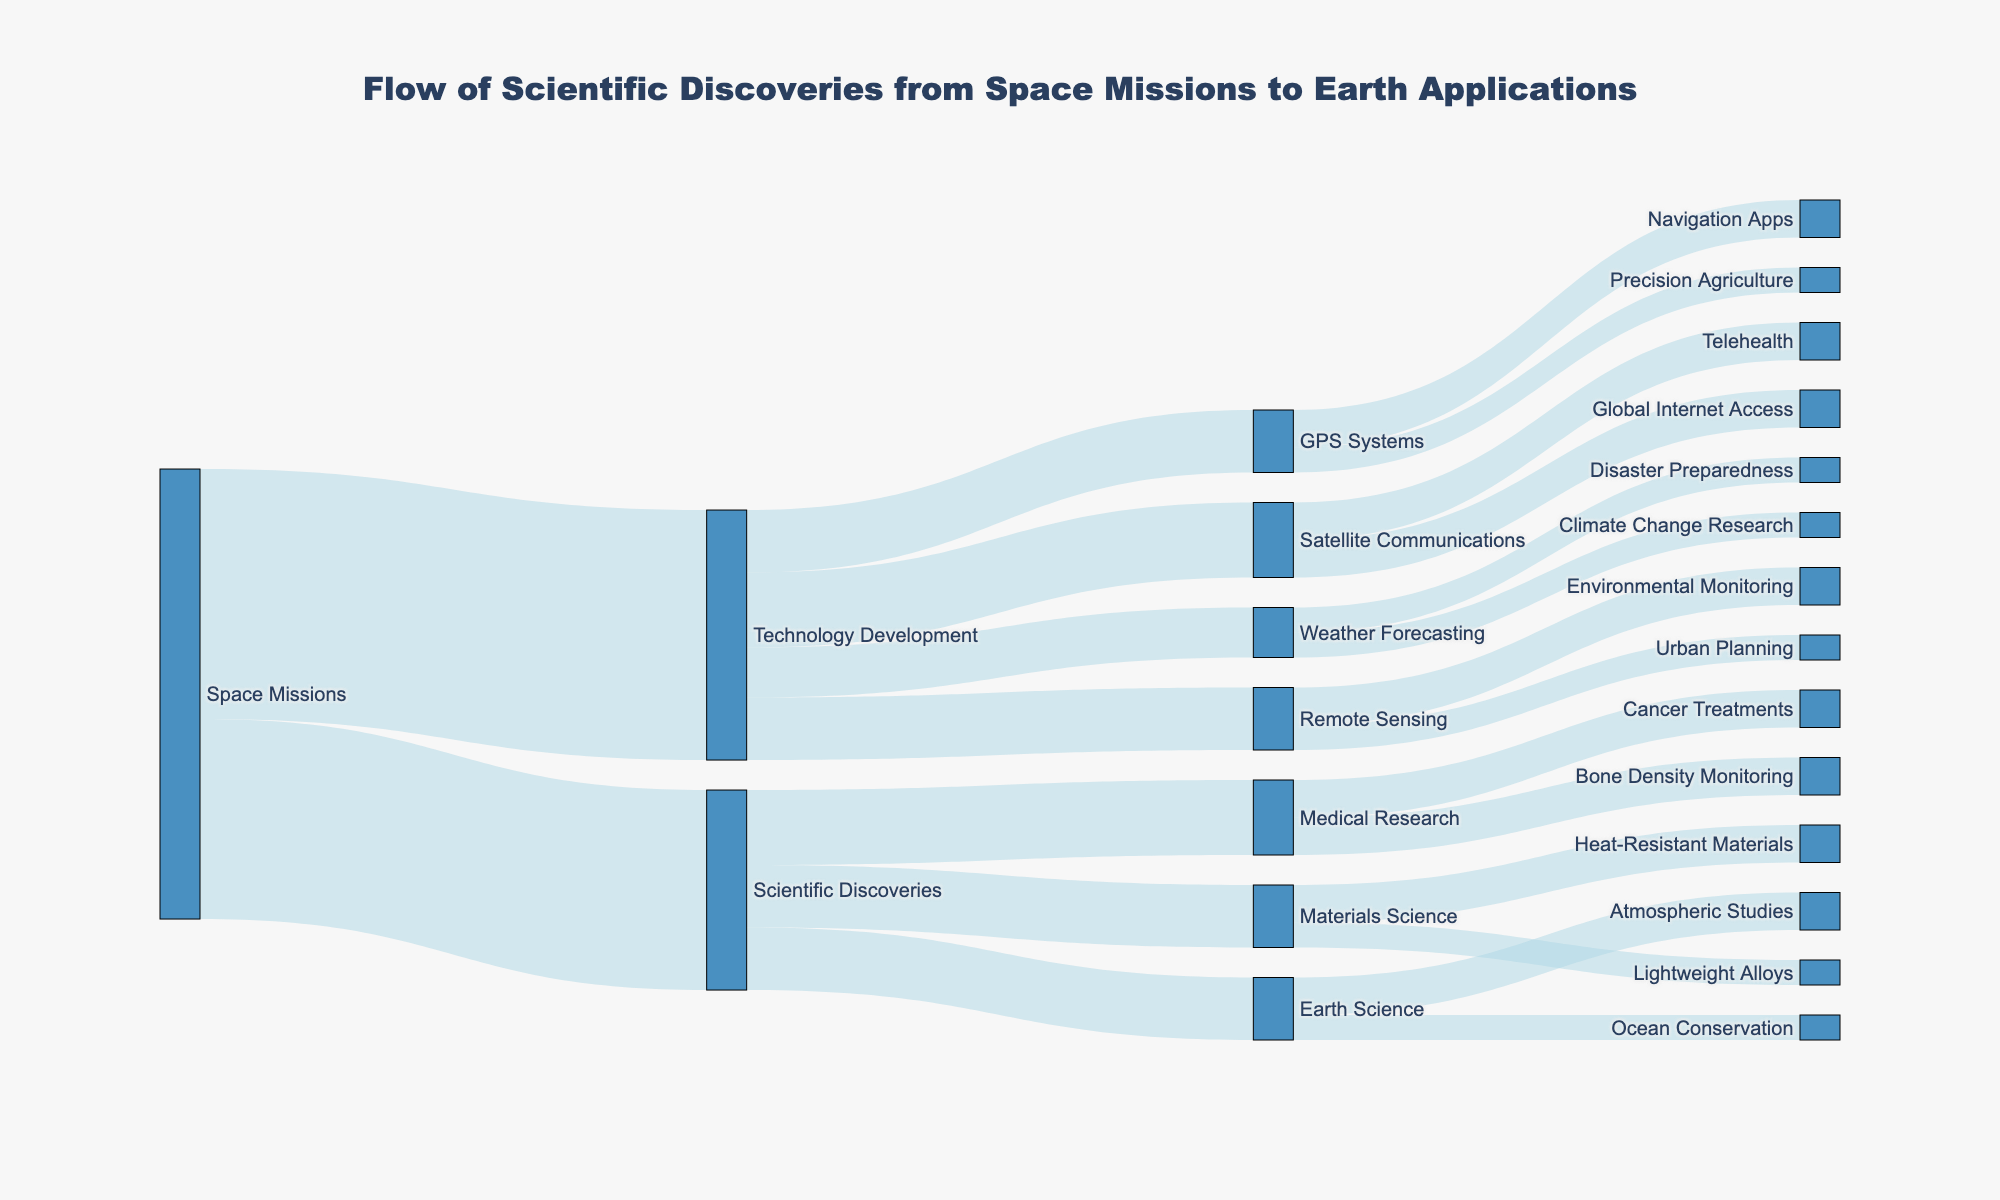What is the main source of the data flow in the diagram? The Sankey Diagram shows that "Space Missions" is the initial source from which the flow begins to different targets like Technology Development and Scientific Discoveries.
Answer: Space Missions How many units of value flow from Technology Development to GPS Systems? According to the figure, there is a flow of 25 units from "Technology Development" to "GPS Systems".
Answer: 25 Which target receives the highest amount of flow from Scientific Discoveries? From the Sankey Diagram, "Medical Research" receives the highest flow from "Scientific Discoveries" with a value of 30 units.
Answer: Medical Research Compare the flow values from Space Missions to Technology Development and from Space Missions to Scientific Discoveries. Which is higher? The diagram shows 100 units flowing from "Space Missions" to "Technology Development" and 80 units to "Scientific Discoveries", so "Space Missions" to "Technology Development" is higher.
Answer: Technology Development What is the combined value of flows receiving from Technology Development to Satellite Communications and GPS Systems? The values are 30 units for Satellite Communications and 25 units for GPS Systems. Their combined value is 30 + 25 = 55 units.
Answer: 55 What specific application areas benefit from the flow starting from Remote Sensing? According to the figure, flows from "Remote Sensing" benefit "Environmental Monitoring" and "Urban Planning".
Answer: Environmental Monitoring, Urban Planning What is the total flow value coming out of Technology Development? Summing the flows from Technology Development to all targets (30+25+20+25), we get a total value of 100 units.
Answer: 100 List the targets connected to Earth Science and the flow values associated with each. The diagram shows that "Earth Science" has flows to "Ocean Conservation" with 10 units and "Atmospheric Studies" with 15 units.
Answer: Ocean Conservation (10), Atmospheric Studies (15) 